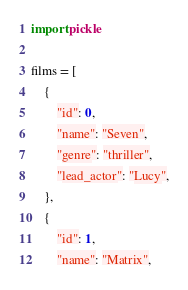Convert code to text. <code><loc_0><loc_0><loc_500><loc_500><_Python_>import pickle

films = [
    {
        "id": 0,
        "name": "Seven",
        "genre": "thriller",
        "lead_actor": "Lucy",
    },
    {
        "id": 1,
        "name": "Matrix",</code> 